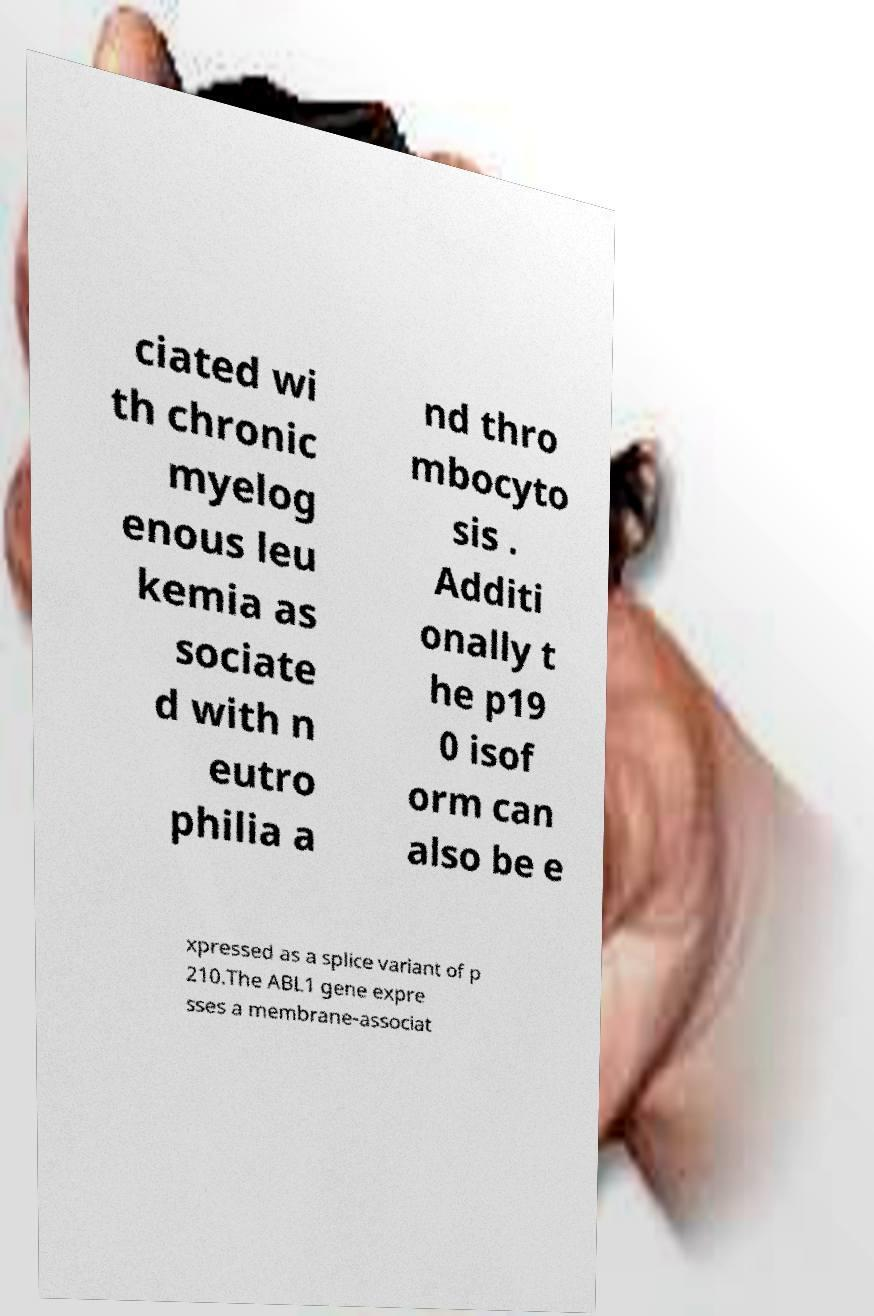There's text embedded in this image that I need extracted. Can you transcribe it verbatim? ciated wi th chronic myelog enous leu kemia as sociate d with n eutro philia a nd thro mbocyto sis . Additi onally t he p19 0 isof orm can also be e xpressed as a splice variant of p 210.The ABL1 gene expre sses a membrane-associat 